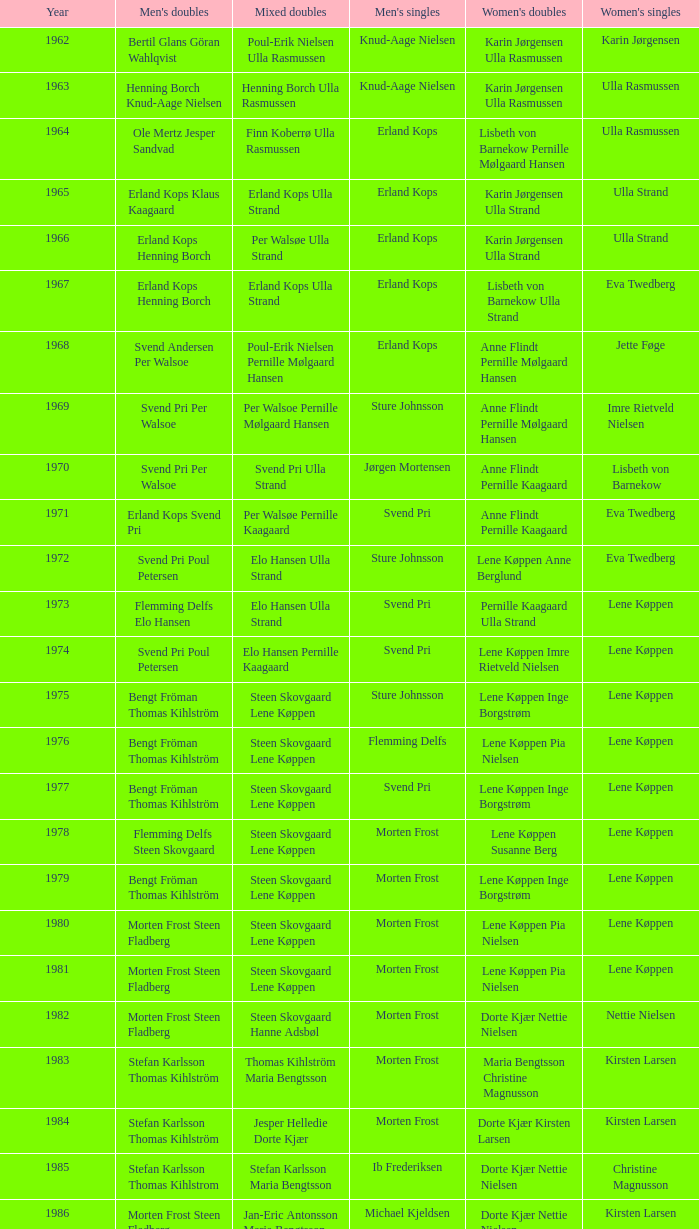Who won the men's doubles the year Pernille Nedergaard won the women's singles? Thomas Stuer-Lauridsen Max Gandrup. Could you parse the entire table? {'header': ['Year', "Men's doubles", 'Mixed doubles', "Men's singles", "Women's doubles", "Women's singles"], 'rows': [['1962', 'Bertil Glans Göran Wahlqvist', 'Poul-Erik Nielsen Ulla Rasmussen', 'Knud-Aage Nielsen', 'Karin Jørgensen Ulla Rasmussen', 'Karin Jørgensen'], ['1963', 'Henning Borch Knud-Aage Nielsen', 'Henning Borch Ulla Rasmussen', 'Knud-Aage Nielsen', 'Karin Jørgensen Ulla Rasmussen', 'Ulla Rasmussen'], ['1964', 'Ole Mertz Jesper Sandvad', 'Finn Koberrø Ulla Rasmussen', 'Erland Kops', 'Lisbeth von Barnekow Pernille Mølgaard Hansen', 'Ulla Rasmussen'], ['1965', 'Erland Kops Klaus Kaagaard', 'Erland Kops Ulla Strand', 'Erland Kops', 'Karin Jørgensen Ulla Strand', 'Ulla Strand'], ['1966', 'Erland Kops Henning Borch', 'Per Walsøe Ulla Strand', 'Erland Kops', 'Karin Jørgensen Ulla Strand', 'Ulla Strand'], ['1967', 'Erland Kops Henning Borch', 'Erland Kops Ulla Strand', 'Erland Kops', 'Lisbeth von Barnekow Ulla Strand', 'Eva Twedberg'], ['1968', 'Svend Andersen Per Walsoe', 'Poul-Erik Nielsen Pernille Mølgaard Hansen', 'Erland Kops', 'Anne Flindt Pernille Mølgaard Hansen', 'Jette Føge'], ['1969', 'Svend Pri Per Walsoe', 'Per Walsoe Pernille Mølgaard Hansen', 'Sture Johnsson', 'Anne Flindt Pernille Mølgaard Hansen', 'Imre Rietveld Nielsen'], ['1970', 'Svend Pri Per Walsoe', 'Svend Pri Ulla Strand', 'Jørgen Mortensen', 'Anne Flindt Pernille Kaagaard', 'Lisbeth von Barnekow'], ['1971', 'Erland Kops Svend Pri', 'Per Walsøe Pernille Kaagaard', 'Svend Pri', 'Anne Flindt Pernille Kaagaard', 'Eva Twedberg'], ['1972', 'Svend Pri Poul Petersen', 'Elo Hansen Ulla Strand', 'Sture Johnsson', 'Lene Køppen Anne Berglund', 'Eva Twedberg'], ['1973', 'Flemming Delfs Elo Hansen', 'Elo Hansen Ulla Strand', 'Svend Pri', 'Pernille Kaagaard Ulla Strand', 'Lene Køppen'], ['1974', 'Svend Pri Poul Petersen', 'Elo Hansen Pernille Kaagaard', 'Svend Pri', 'Lene Køppen Imre Rietveld Nielsen', 'Lene Køppen'], ['1975', 'Bengt Fröman Thomas Kihlström', 'Steen Skovgaard Lene Køppen', 'Sture Johnsson', 'Lene Køppen Inge Borgstrøm', 'Lene Køppen'], ['1976', 'Bengt Fröman Thomas Kihlström', 'Steen Skovgaard Lene Køppen', 'Flemming Delfs', 'Lene Køppen Pia Nielsen', 'Lene Køppen'], ['1977', 'Bengt Fröman Thomas Kihlström', 'Steen Skovgaard Lene Køppen', 'Svend Pri', 'Lene Køppen Inge Borgstrøm', 'Lene Køppen'], ['1978', 'Flemming Delfs Steen Skovgaard', 'Steen Skovgaard Lene Køppen', 'Morten Frost', 'Lene Køppen Susanne Berg', 'Lene Køppen'], ['1979', 'Bengt Fröman Thomas Kihlström', 'Steen Skovgaard Lene Køppen', 'Morten Frost', 'Lene Køppen Inge Borgstrøm', 'Lene Køppen'], ['1980', 'Morten Frost Steen Fladberg', 'Steen Skovgaard Lene Køppen', 'Morten Frost', 'Lene Køppen Pia Nielsen', 'Lene Køppen'], ['1981', 'Morten Frost Steen Fladberg', 'Steen Skovgaard Lene Køppen', 'Morten Frost', 'Lene Køppen Pia Nielsen', 'Lene Køppen'], ['1982', 'Morten Frost Steen Fladberg', 'Steen Skovgaard Hanne Adsbøl', 'Morten Frost', 'Dorte Kjær Nettie Nielsen', 'Nettie Nielsen'], ['1983', 'Stefan Karlsson Thomas Kihlström', 'Thomas Kihlström Maria Bengtsson', 'Morten Frost', 'Maria Bengtsson Christine Magnusson', 'Kirsten Larsen'], ['1984', 'Stefan Karlsson Thomas Kihlström', 'Jesper Helledie Dorte Kjær', 'Morten Frost', 'Dorte Kjær Kirsten Larsen', 'Kirsten Larsen'], ['1985', 'Stefan Karlsson Thomas Kihlstrom', 'Stefan Karlsson Maria Bengtsson', 'Ib Frederiksen', 'Dorte Kjær Nettie Nielsen', 'Christine Magnusson'], ['1986', 'Morten Frost Steen Fladberg', 'Jan-Eric Antonsson Maria Bengtsson', 'Michael Kjeldsen', 'Dorte Kjær Nettie Nielsen', 'Kirsten Larsen'], ['1987', 'Steen Fladberg Jan Paulsen', 'Jesper Knudsen Nettie Nielsen', 'Michael Kjeldsen', 'Dorte Kjær Nettie Nielsen', 'Christina Bostofte'], ['1988', 'Jens Peter Nierhoff Michael Kjeldsen', 'Jesper Knudsen Nettie Nielsen', 'Morten Frost', 'Dorte Kjær Nettie Nielsen', 'Kirsten Larsen'], ['1990', 'Thomas Stuer-Lauridsen Max Gandrup', 'Thomas Lund Pernille Dupont', 'Poul Erik Hoyer Larsen', 'Dorte Kjær Lotte Olsen', 'Pernille Nedergaard'], ['1992', 'Jon Holst-Christensen Jan Paulsen', 'Par Gunnar Jönsson Maria Bengtsson', 'Thomas Stuer-Lauridsen', 'Christine Magnusson Lim Xiao Qing', 'Christine Magnusson'], ['1995', 'Michael Søgaard Henrik Svarrer', 'Michael Søgaard Rikke Olsen', 'Thomas Stuer-Lauridsen', 'Rikke Olsen Helene Kirkegaard', 'Lim Xiao Qing'], ['1997', 'Jesper Larsen Jens Eriksen', 'Jens Eriksen Marlene Thomsen', 'Peter Rasmussen', 'Rikke Olsen Helene Kirkegaard', 'Camilla Martin'], ['1999', 'Thomas Stavngaard Lars Paaske', 'Fredrik Bergström Jenny Karlsson', 'Thomas Johansson', 'Ann-Lou Jørgensen Mette Schjoldager', 'Mette Sørensen']]} 